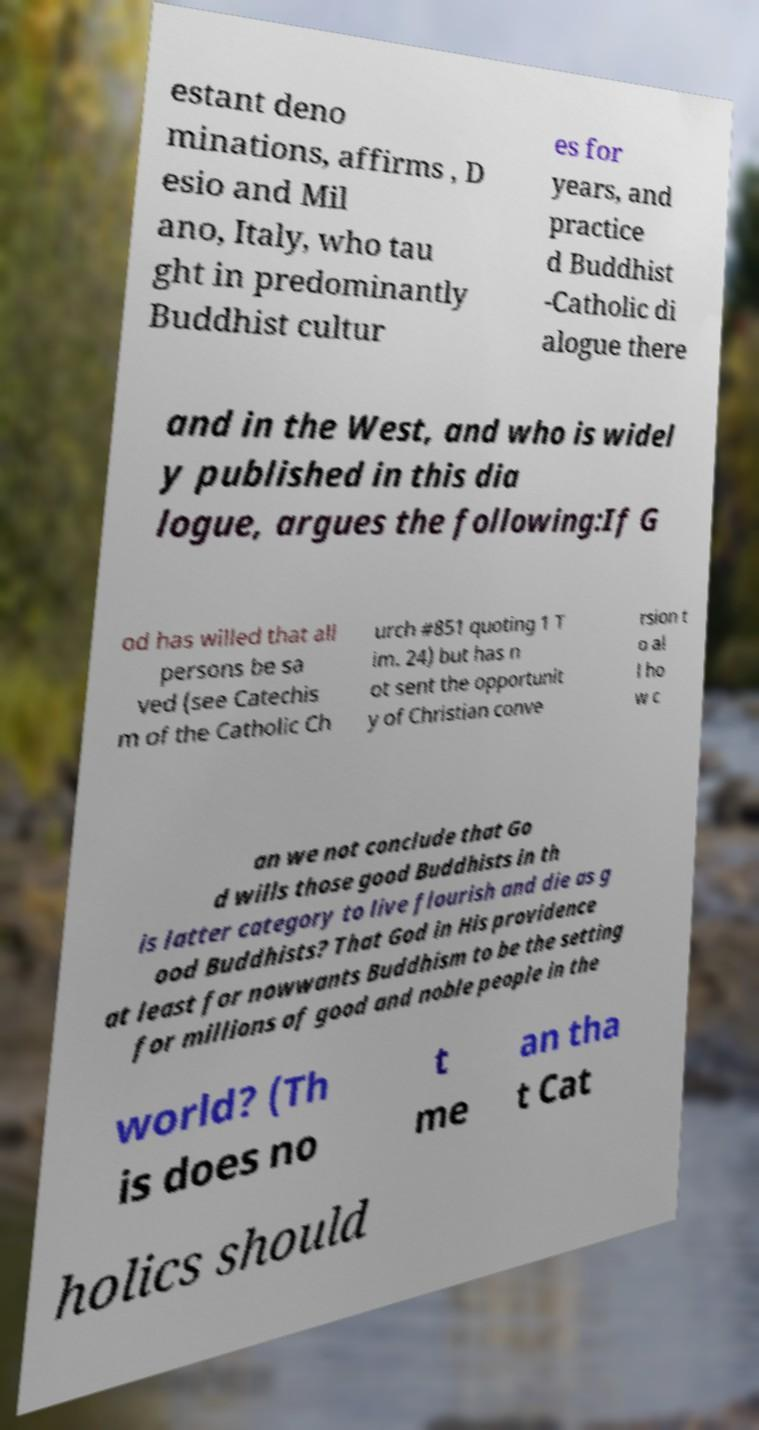Can you read and provide the text displayed in the image?This photo seems to have some interesting text. Can you extract and type it out for me? estant deno minations, affirms , D esio and Mil ano, Italy, who tau ght in predominantly Buddhist cultur es for years, and practice d Buddhist -Catholic di alogue there and in the West, and who is widel y published in this dia logue, argues the following:If G od has willed that all persons be sa ved (see Catechis m of the Catholic Ch urch #851 quoting 1 T im. 24) but has n ot sent the opportunit y of Christian conve rsion t o al l ho w c an we not conclude that Go d wills those good Buddhists in th is latter category to live flourish and die as g ood Buddhists? That God in His providence at least for nowwants Buddhism to be the setting for millions of good and noble people in the world? (Th is does no t me an tha t Cat holics should 